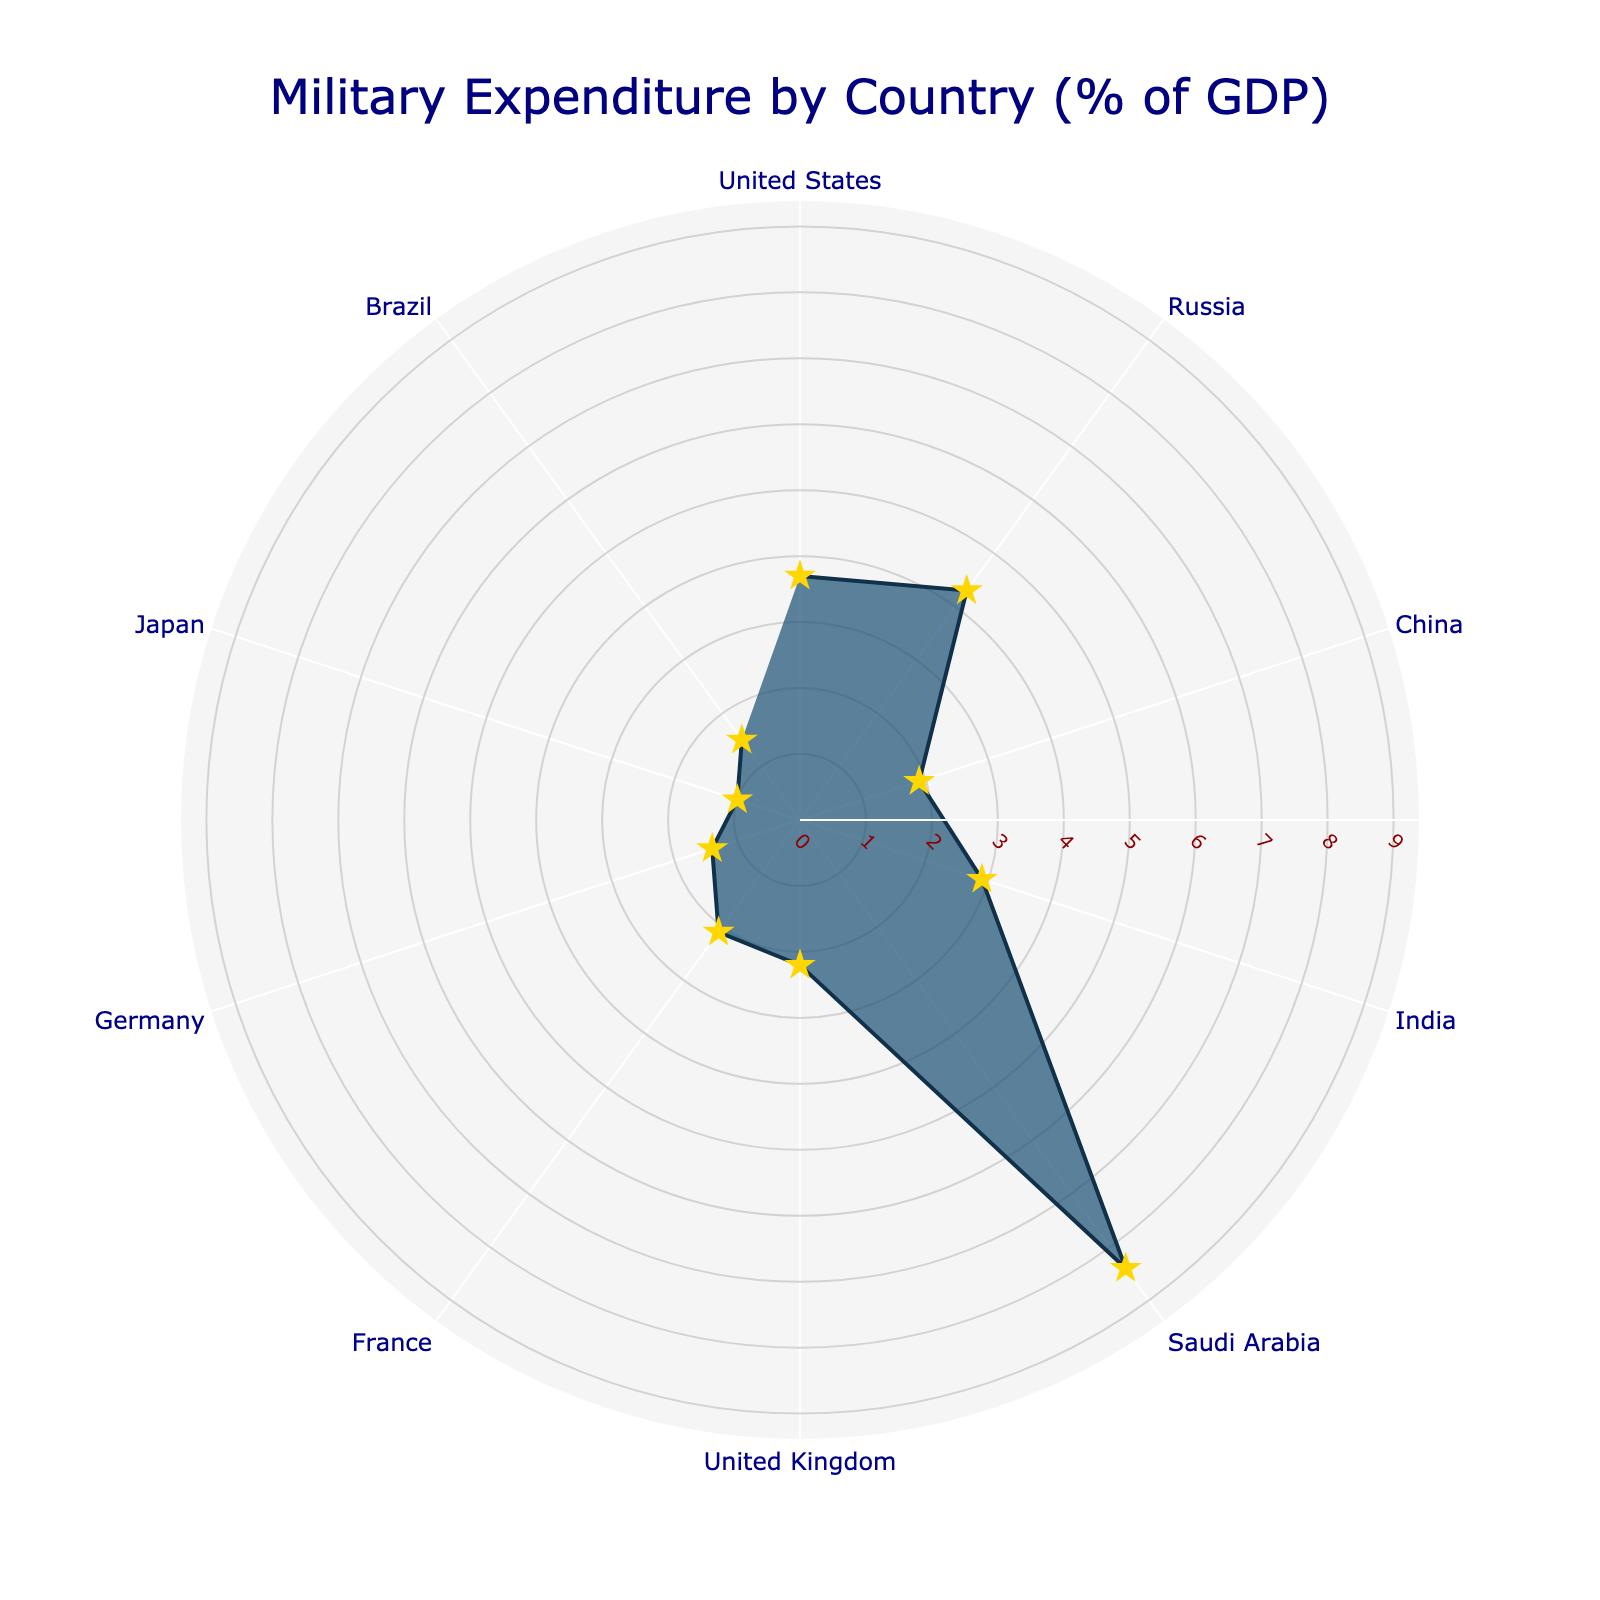What's the title of the figure? The title is typically displayed prominently at the top of the figure. The given code specifies the title should be "Military Expenditure by Country (% of GDP)".
Answer: Military Expenditure by Country (% of GDP) How many countries are represented in the figure? By counting the unique labels in the chart's angular axis, we can see there are ten countries displayed.
Answer: 10 Which country has the highest military expenditure relative to GDP? The country with the highest value on the radial axis represents the highest expenditure relative to GDP. According to the figure, Saudi Arabia has the highest percentage at 8.4%.
Answer: Saudi Arabia What is the combined military expenditure as a percentage of GDP for United States and Russia? The expenditures for the United States and Russia are 3.7% and 4.3%, respectively. Adding these values together gives 3.7 + 4.3 = 8.0%.
Answer: 8.0% Which country has the lowest military expenditure relative to GDP? The country with the smallest value on the radial axis represents the lowest expenditure relative to GDP. The figure shows Japan has the lowest percentage at 1.0%.
Answer: Japan What is the difference in military expenditure relative to GDP between India and China? India's expenditure is 2.9%, and China's is 1.9%. Subtracting these values gives 2.9 - 1.9 = 1.0%.
Answer: 1.0% Compare the military expenditures of the United Kingdom and France relative to GDP. Which is higher? The chart shows that the United Kingdom has an expenditure of 2.2%, while France has an expenditure of 2.1%. Therefore, the United Kingdom has a slightly higher military expenditure.
Answer: United Kingdom Which countries have a military expenditure relative to GDP that is below 2%? By examining the radial axis values, the countries with expenditures below 2% are China (1.9%), Germany (1.4%), Japan (1.0%), and Brazil (1.5%).
Answer: China, Germany, Japan, Brazil What is the average military expenditure relative to GDP of all the countries represented? Adding all the percentages together and dividing by the number of countries: (3.7 + 4.3 + 1.9 + 2.9 + 8.4 + 2.2 + 2.1 + 1.4 + 1.0 + 1.5) / 10. The sum is 29.4, hence the average is 29.4 / 10 = 2.94%.
Answer: 2.94% How does the military expenditure of Brazil compare to Germany? The figure shows Brazil has an expenditure of 1.5% and Germany 1.4%. Brazil's expenditure is slightly higher.
Answer: Brazil 